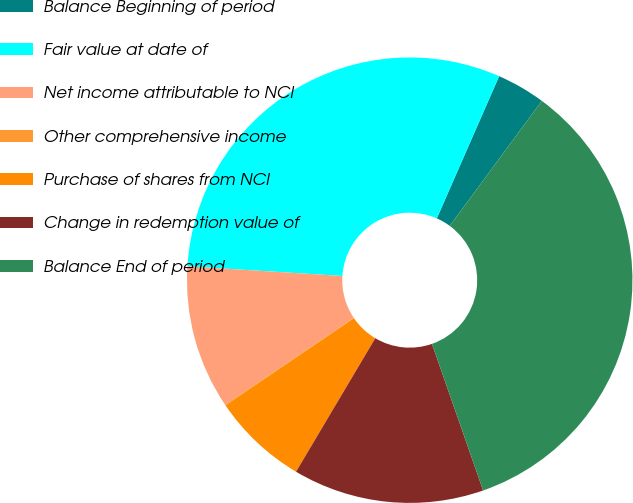Convert chart to OTSL. <chart><loc_0><loc_0><loc_500><loc_500><pie_chart><fcel>Balance Beginning of period<fcel>Fair value at date of<fcel>Net income attributable to NCI<fcel>Other comprehensive income<fcel>Purchase of shares from NCI<fcel>Change in redemption value of<fcel>Balance End of period<nl><fcel>3.53%<fcel>30.58%<fcel>10.42%<fcel>0.08%<fcel>6.97%<fcel>13.87%<fcel>34.55%<nl></chart> 